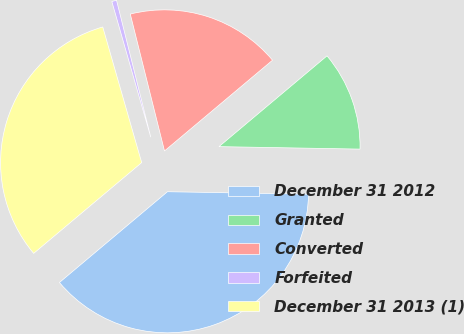Convert chart to OTSL. <chart><loc_0><loc_0><loc_500><loc_500><pie_chart><fcel>December 31 2012<fcel>Granted<fcel>Converted<fcel>Forfeited<fcel>December 31 2013 (1)<nl><fcel>38.6%<fcel>11.4%<fcel>17.78%<fcel>0.55%<fcel>31.68%<nl></chart> 